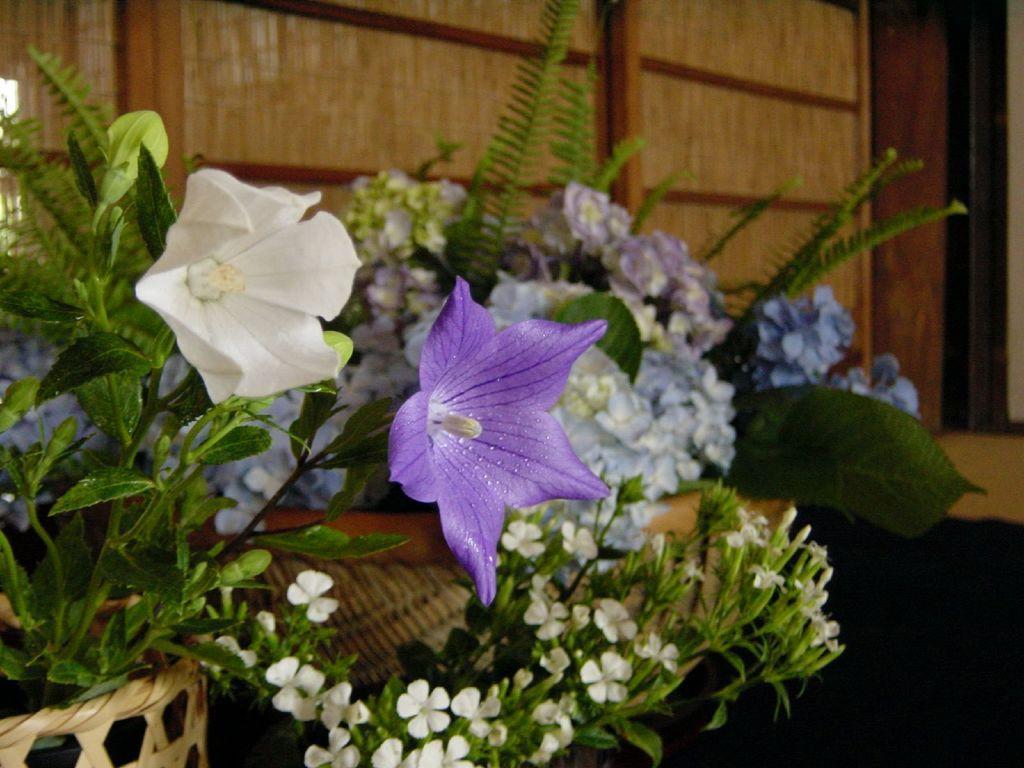In one or two sentences, can you explain what this image depicts? In the foreground of this image, there are flowers to the plants are in the basket. In the background, it seems like a wooden wall. 